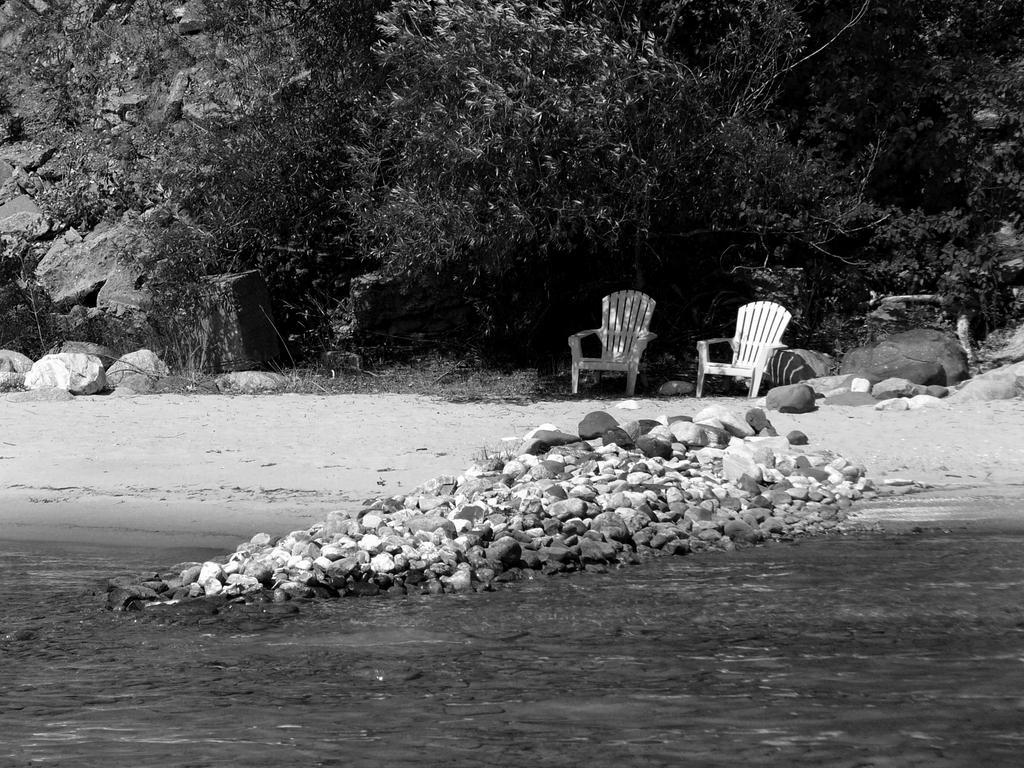Could you give a brief overview of what you see in this image? In this picture we can see water and few rocks, in the background we can see few chairs and trees, it is a black and white photography. 